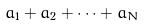Convert formula to latex. <formula><loc_0><loc_0><loc_500><loc_500>a _ { 1 } + a _ { 2 } + \dots + a _ { N }</formula> 